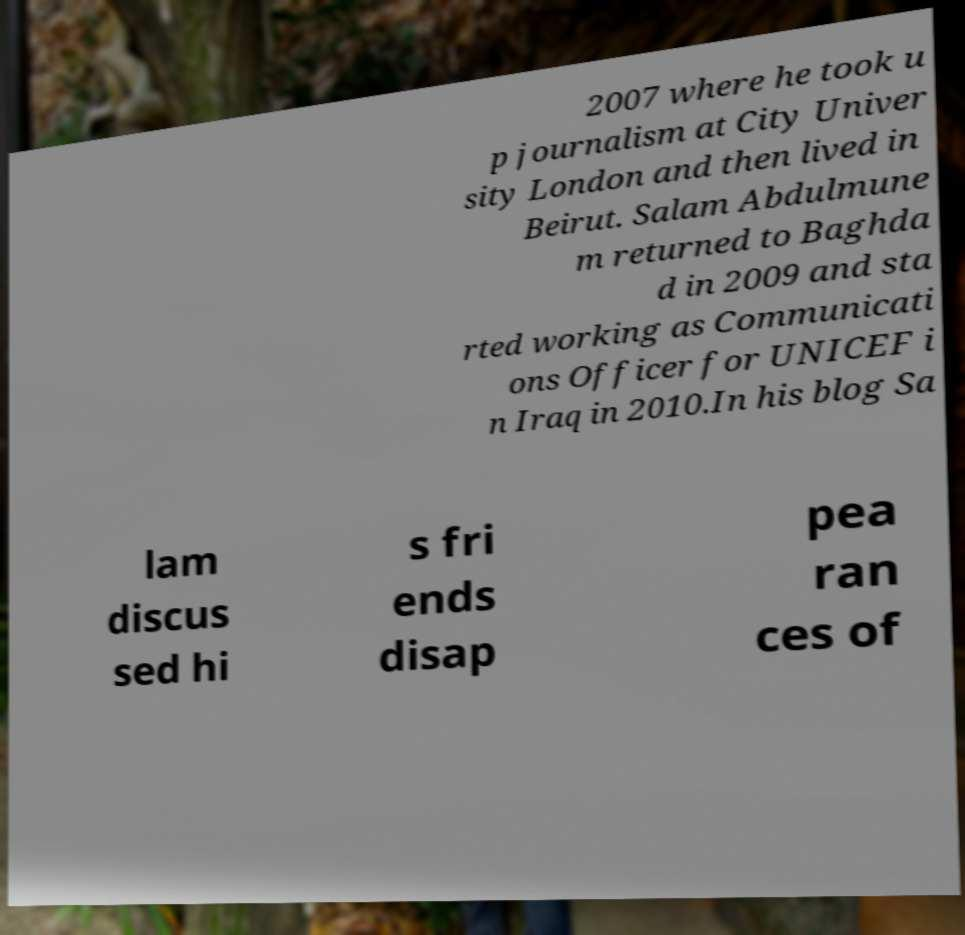Can you read and provide the text displayed in the image?This photo seems to have some interesting text. Can you extract and type it out for me? 2007 where he took u p journalism at City Univer sity London and then lived in Beirut. Salam Abdulmune m returned to Baghda d in 2009 and sta rted working as Communicati ons Officer for UNICEF i n Iraq in 2010.In his blog Sa lam discus sed hi s fri ends disap pea ran ces of 